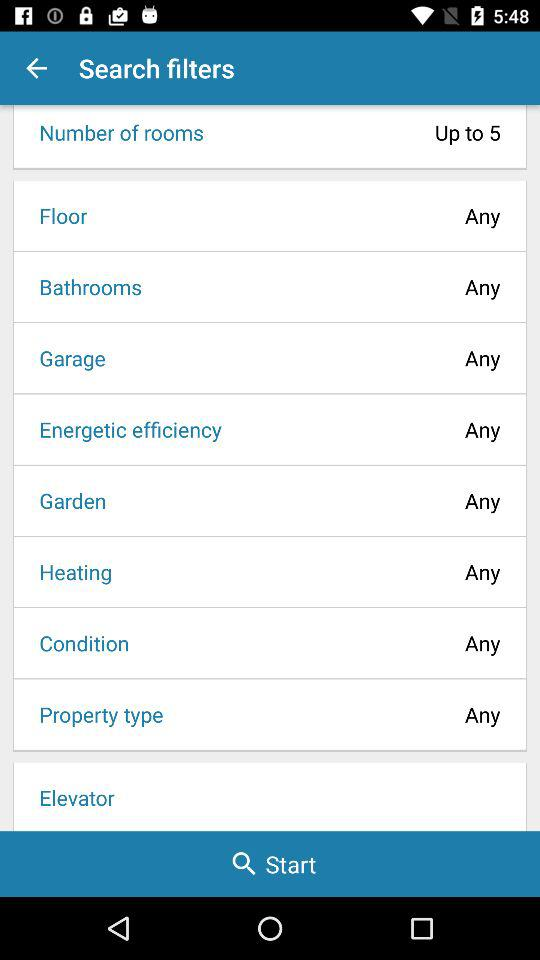What is the selected number of rooms? The room is up to 5. 